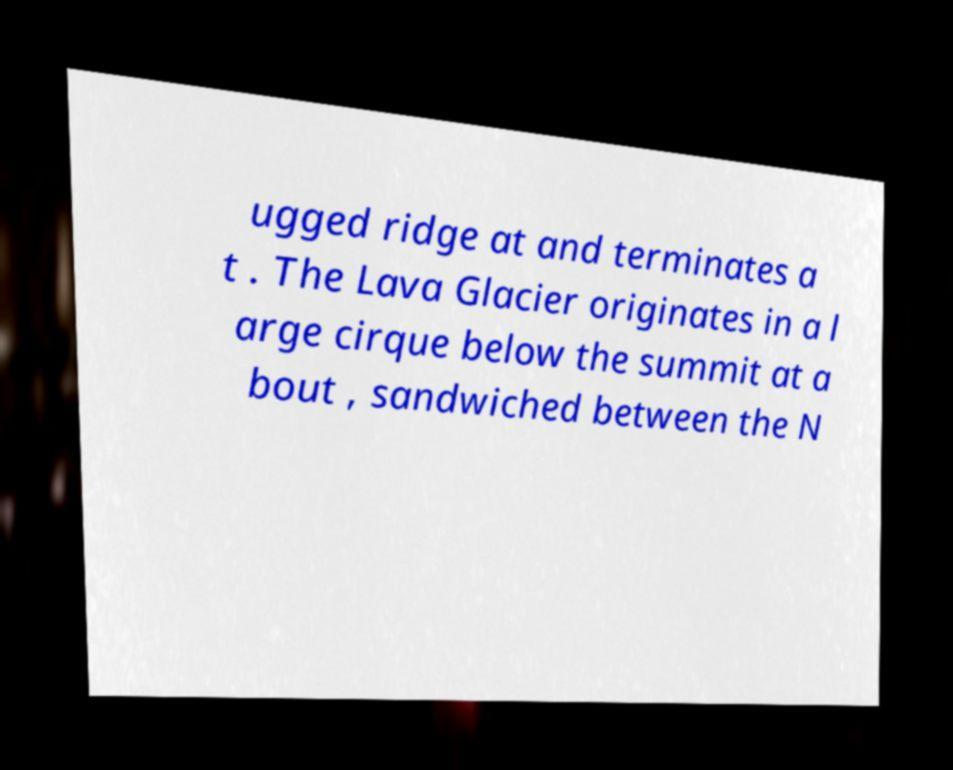Could you assist in decoding the text presented in this image and type it out clearly? ugged ridge at and terminates a t . The Lava Glacier originates in a l arge cirque below the summit at a bout , sandwiched between the N 